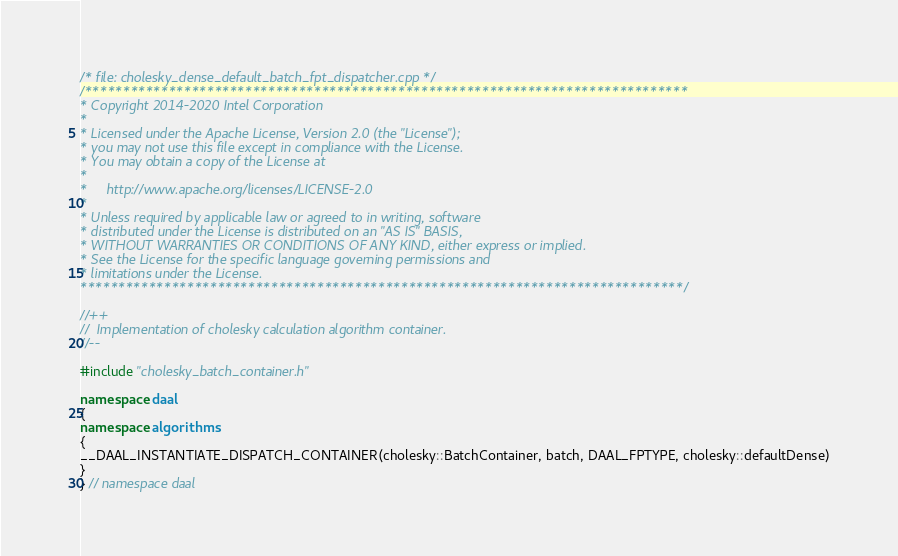Convert code to text. <code><loc_0><loc_0><loc_500><loc_500><_C++_>/* file: cholesky_dense_default_batch_fpt_dispatcher.cpp */
/*******************************************************************************
* Copyright 2014-2020 Intel Corporation
*
* Licensed under the Apache License, Version 2.0 (the "License");
* you may not use this file except in compliance with the License.
* You may obtain a copy of the License at
*
*     http://www.apache.org/licenses/LICENSE-2.0
*
* Unless required by applicable law or agreed to in writing, software
* distributed under the License is distributed on an "AS IS" BASIS,
* WITHOUT WARRANTIES OR CONDITIONS OF ANY KIND, either express or implied.
* See the License for the specific language governing permissions and
* limitations under the License.
*******************************************************************************/

//++
//  Implementation of cholesky calculation algorithm container.
//--

#include "cholesky_batch_container.h"

namespace daal
{
namespace algorithms
{
__DAAL_INSTANTIATE_DISPATCH_CONTAINER(cholesky::BatchContainer, batch, DAAL_FPTYPE, cholesky::defaultDense)
}
} // namespace daal
</code> 